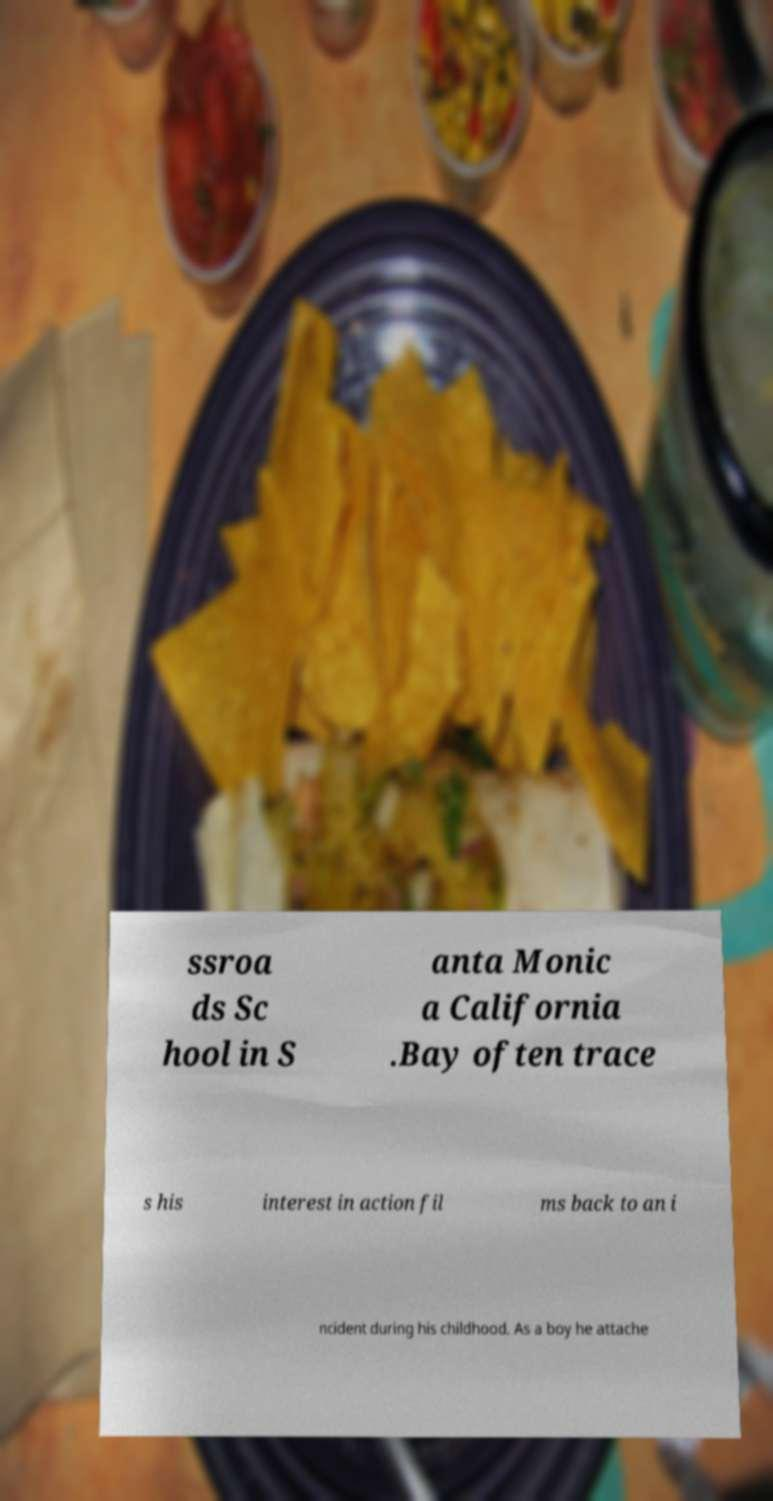Could you assist in decoding the text presented in this image and type it out clearly? ssroa ds Sc hool in S anta Monic a California .Bay often trace s his interest in action fil ms back to an i ncident during his childhood. As a boy he attache 